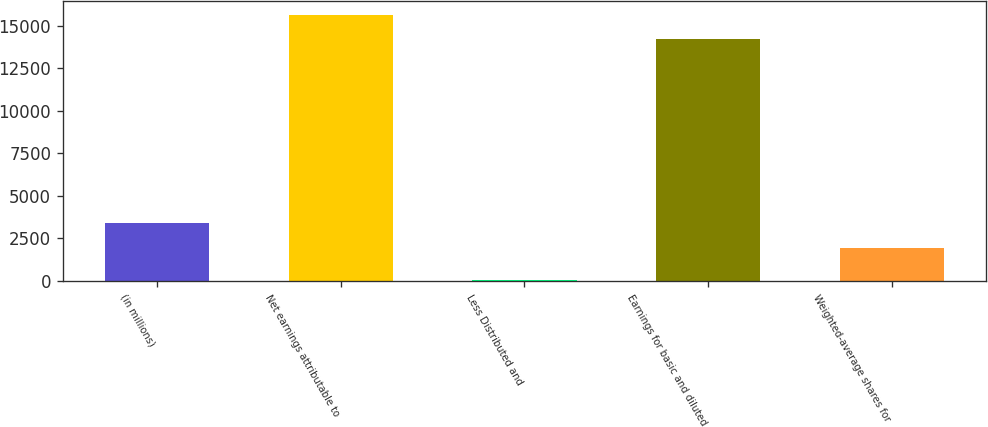Convert chart. <chart><loc_0><loc_0><loc_500><loc_500><bar_chart><fcel>(in millions)<fcel>Net earnings attributable to<fcel>Less Distributed and<fcel>Earnings for basic and diluted<fcel>Weighted-average shares for<nl><fcel>3373.5<fcel>15636.5<fcel>24<fcel>14215<fcel>1952<nl></chart> 